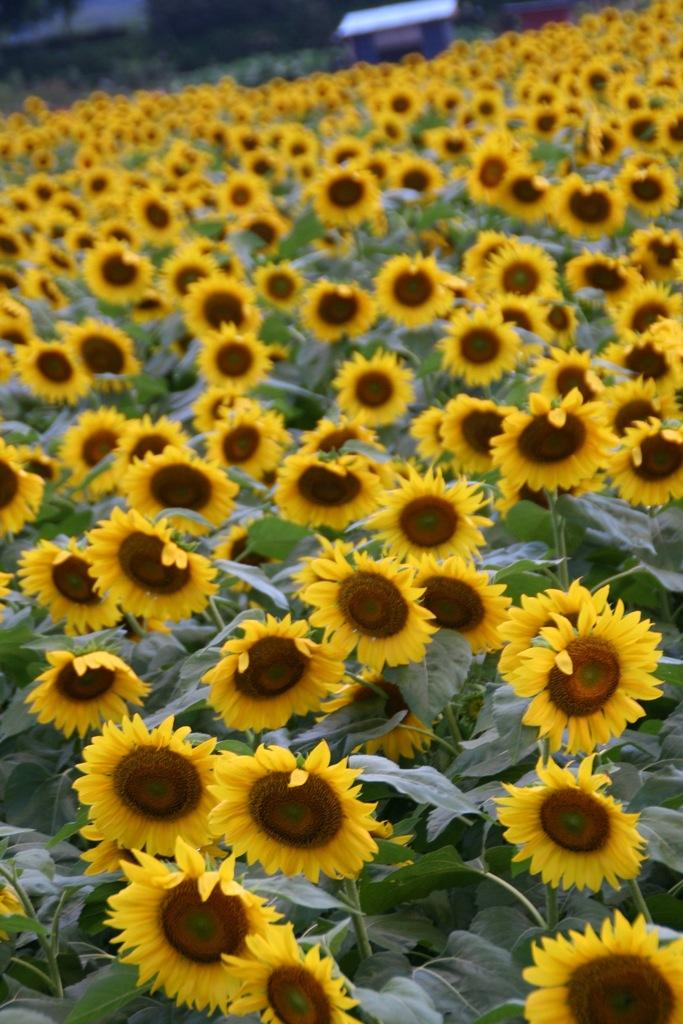What type of flowers are in the foreground of the image? There are sunflowers in the foreground of the image. What else can be seen in the image besides the sunflowers? There are plants in the image. Can you describe the object visible at the top of the image? Unfortunately, the facts provided do not give any information about the object at the top of the image. What type of polish is being applied to the skate in the image? There is no skate or polish present in the image. Is the cap visible in the image? The facts provided do not mention a cap, so we cannot determine if it is visible in the image. 